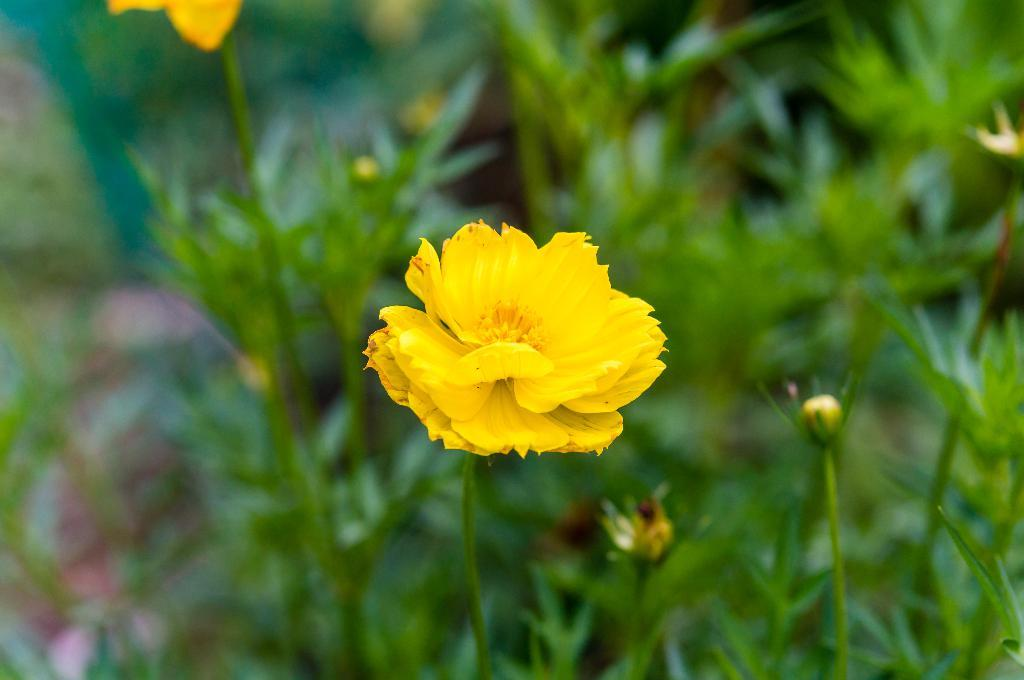What type of flower is in the image? There is a yellow flower in the image. What part of the flower is visible? The flower has a stem. What else can be seen in the background of the image? There are leaves visible in the background of the image, but they are blurred. What is the girl doing at the protest on the trail in the image? There is no girl, protest, or trail present in the image; it only features a yellow flower with a stem and blurred leaves in the background. 